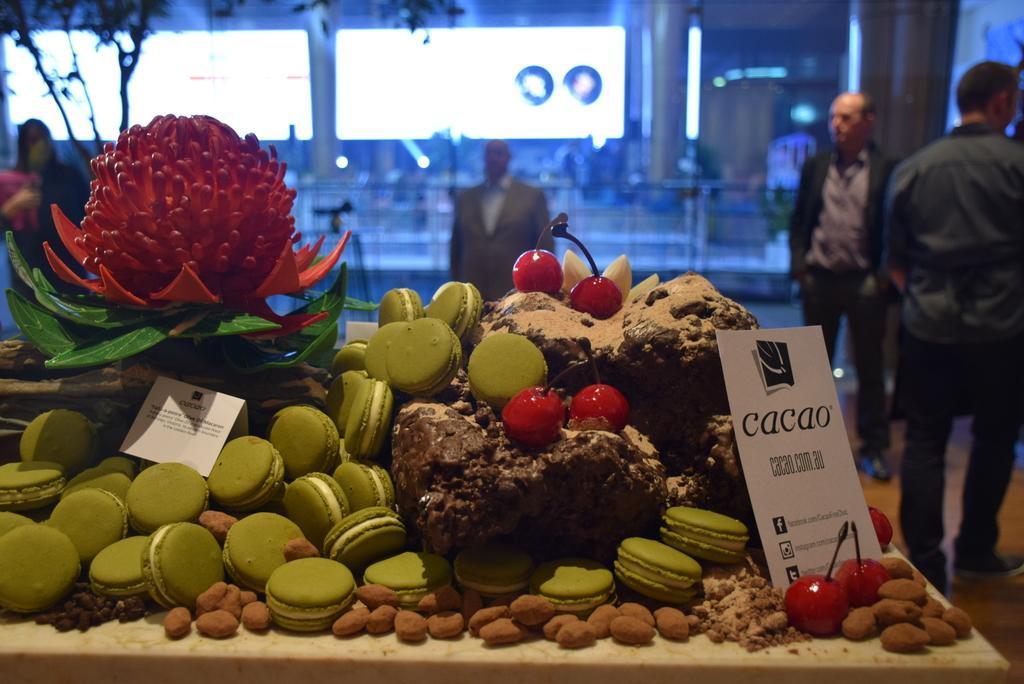Please provide a concise description of this image. As we can see in the image there are few people here and there, screen, wall and table. On table there are nuts, cherries, biscuits and a fruit. 